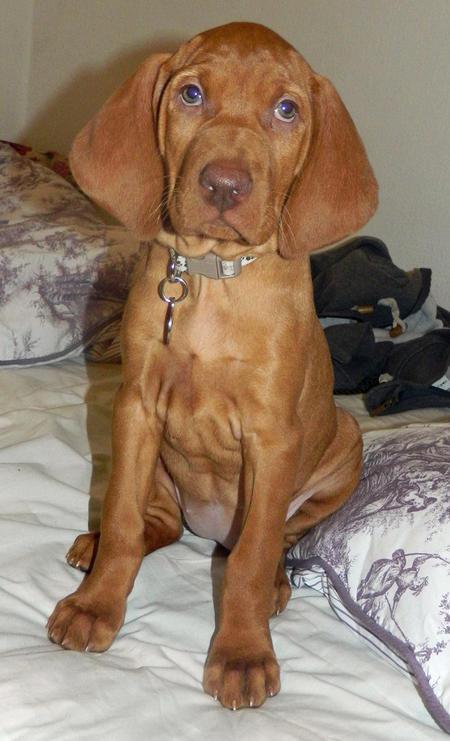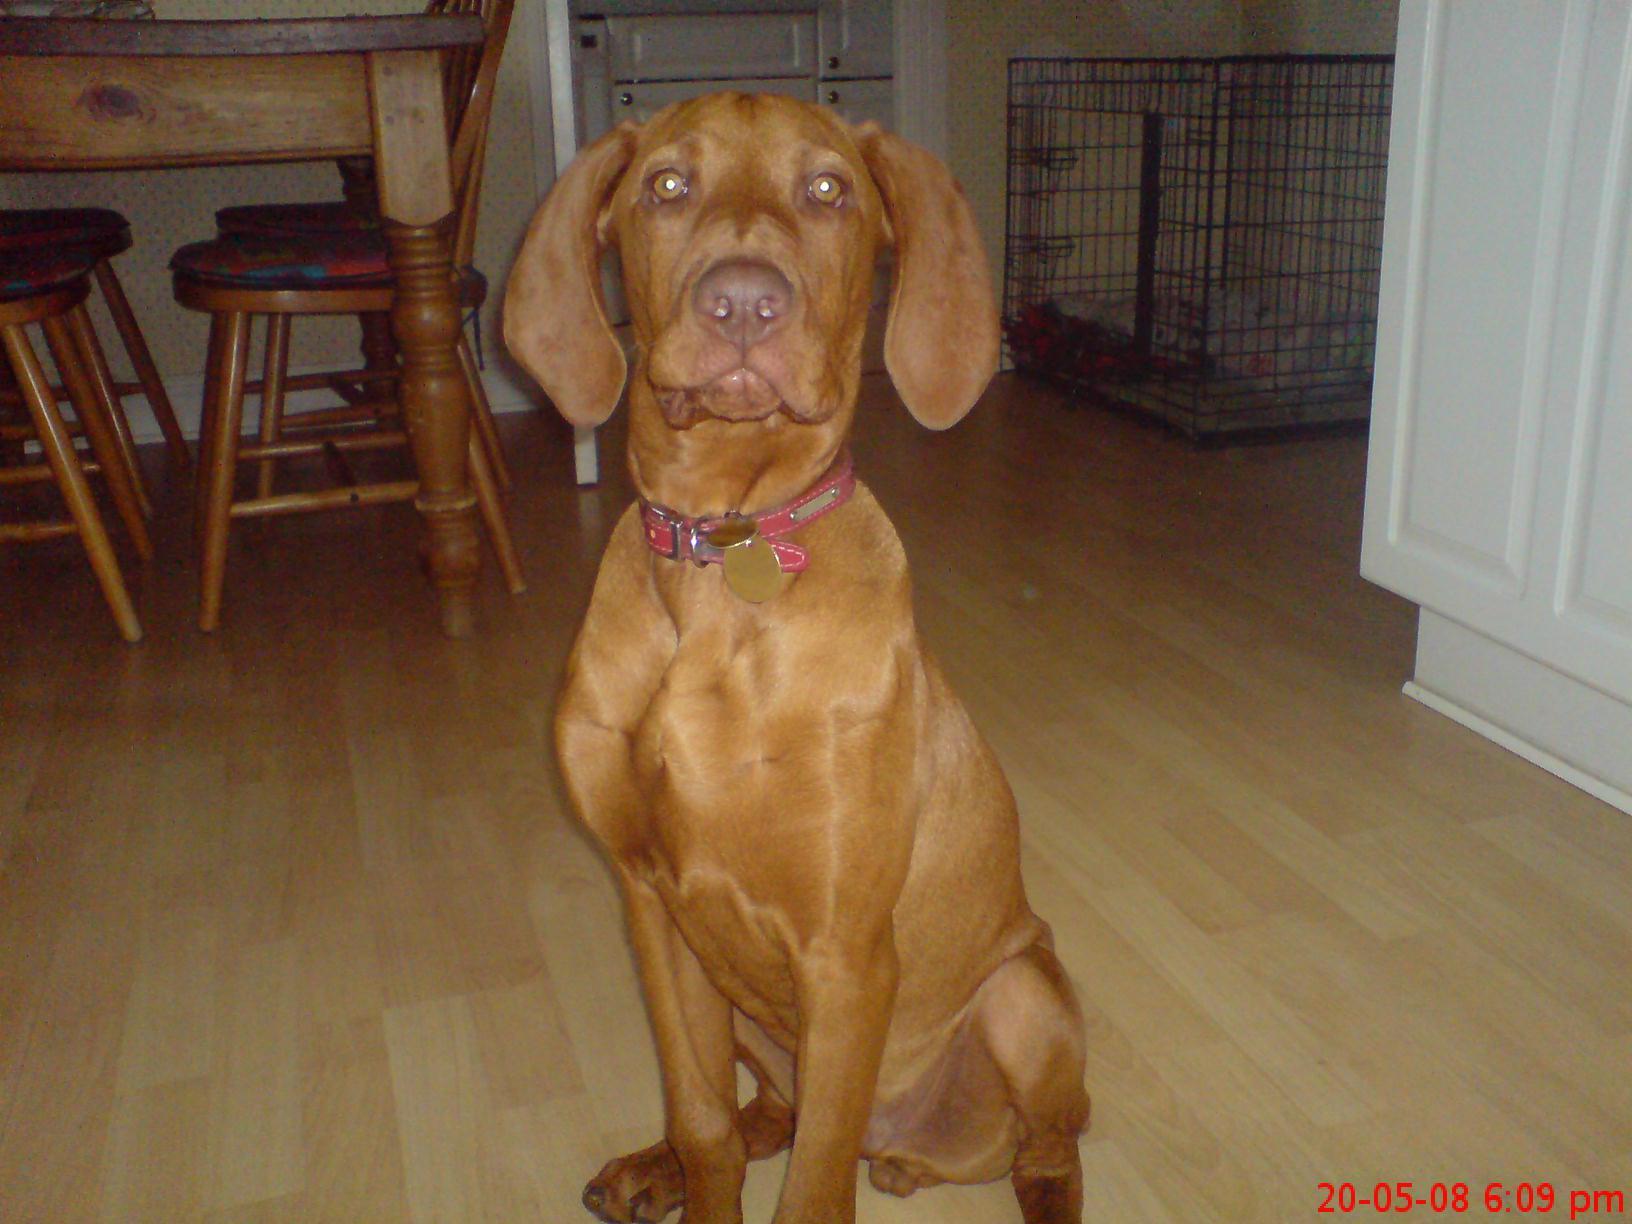The first image is the image on the left, the second image is the image on the right. Given the left and right images, does the statement "Left and right images each contain a red-orange dog sitting upright, turned forward, and wearing a collar - but only one of the dogs pictured has a tag on a ring dangling from its collar." hold true? Answer yes or no. Yes. The first image is the image on the left, the second image is the image on the right. Assess this claim about the two images: "Two dogs are sitting.". Correct or not? Answer yes or no. Yes. 